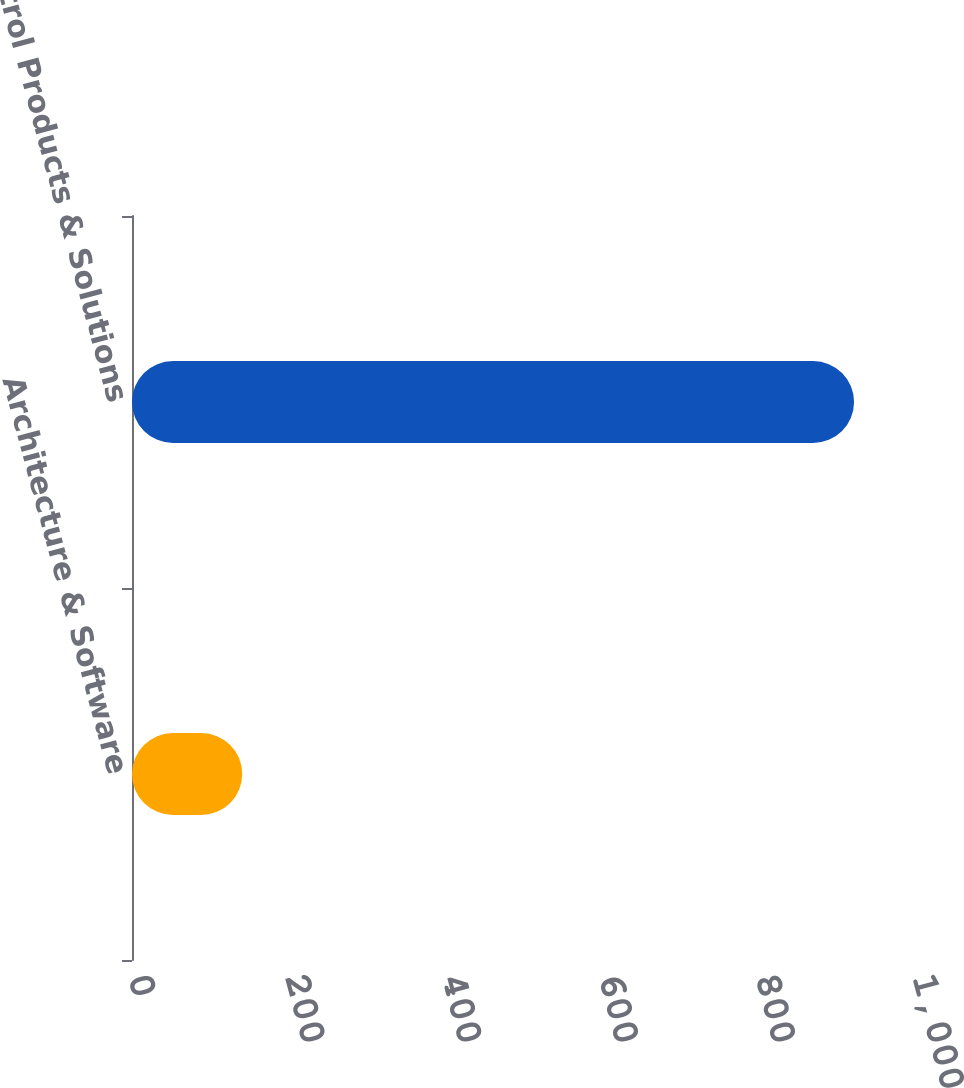<chart> <loc_0><loc_0><loc_500><loc_500><bar_chart><fcel>Architecture & Software<fcel>Control Products & Solutions<nl><fcel>140.6<fcel>921<nl></chart> 